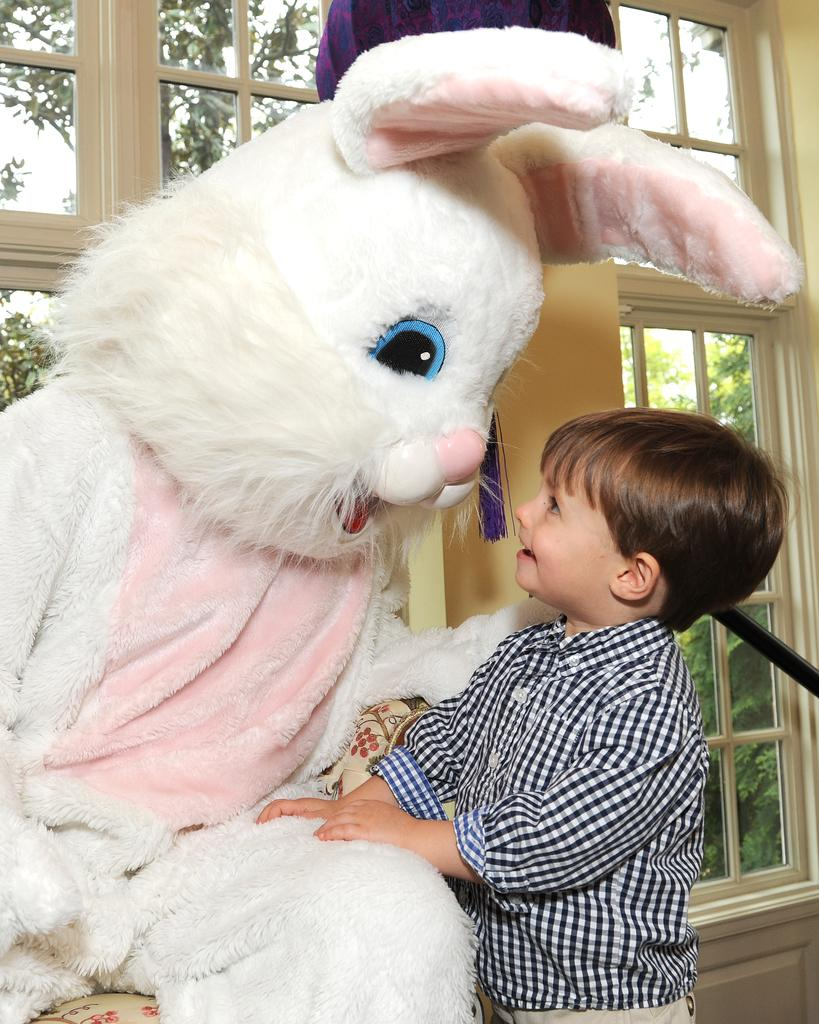What is the main subject of the image? There is a kid in the center of the image. What is the kid doing in the image? The kid is standing at a toy. What can be seen in the background of the image? There are windows, trees, and the sky visible in the background of the image. What type of credit card is the kid holding in the image? There is no credit card present in the image; the kid is standing at a toy. How many rings can be seen on the kid's fingers in the image? There are no rings visible on the kid's fingers in the image. 